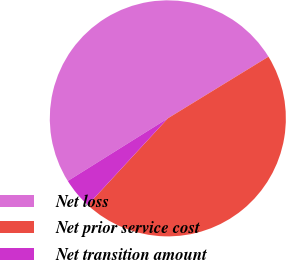Convert chart. <chart><loc_0><loc_0><loc_500><loc_500><pie_chart><fcel>Net loss<fcel>Net prior service cost<fcel>Net transition amount<nl><fcel>50.15%<fcel>45.62%<fcel>4.23%<nl></chart> 